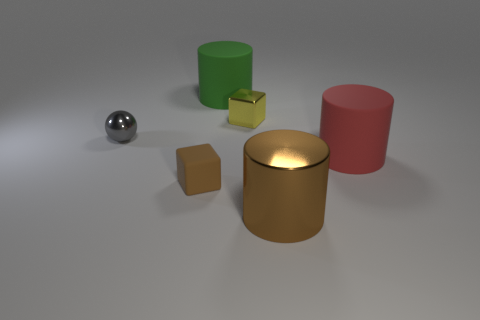There is a tiny rubber object that is the same color as the metal cylinder; what shape is it?
Your response must be concise. Cube. What is the shape of the tiny metal object in front of the small yellow thing to the left of the large brown metallic cylinder?
Provide a short and direct response. Sphere. How many things are large cylinders to the right of the large brown object or cylinders that are behind the red cylinder?
Provide a short and direct response. 2. What is the shape of the small yellow thing that is the same material as the big brown thing?
Provide a succinct answer. Cube. Are there any other things that are the same color as the small matte block?
Keep it short and to the point. Yes. There is a big green object that is the same shape as the big brown object; what is its material?
Your response must be concise. Rubber. What number of other objects are there of the same size as the red cylinder?
Provide a short and direct response. 2. What is the gray thing made of?
Your answer should be very brief. Metal. Is the number of big green matte cylinders that are in front of the green cylinder greater than the number of brown shiny objects?
Offer a very short reply. No. Are any yellow objects visible?
Ensure brevity in your answer.  Yes. 